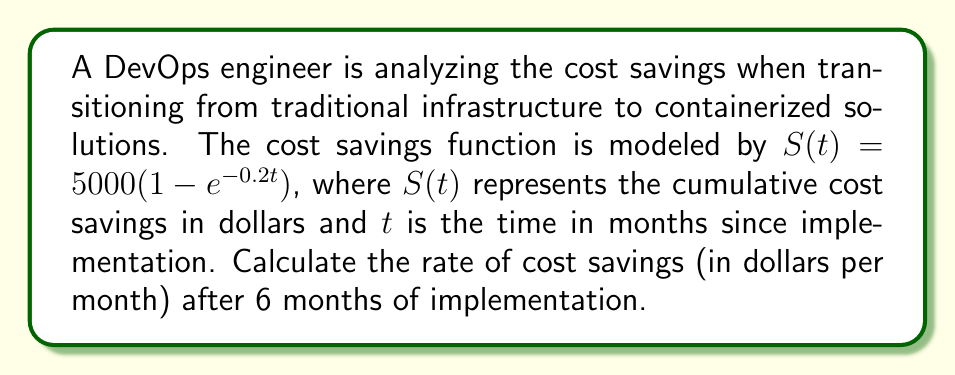What is the answer to this math problem? To find the rate of cost savings after 6 months, we need to calculate the derivative of the cost savings function $S(t)$ and evaluate it at $t=6$. Let's follow these steps:

1) The cost savings function is given by:
   $$S(t) = 5000(1 - e^{-0.2t})$$

2) To find the rate of change, we need to differentiate $S(t)$ with respect to $t$:
   $$\frac{dS}{dt} = 5000 \cdot \frac{d}{dt}(1 - e^{-0.2t})$$

3) Using the chain rule:
   $$\frac{dS}{dt} = 5000 \cdot (-1) \cdot (-0.2e^{-0.2t})$$

4) Simplifying:
   $$\frac{dS}{dt} = 1000e^{-0.2t}$$

5) This derivative represents the instantaneous rate of cost savings at any time $t$.

6) To find the rate of cost savings after 6 months, we evaluate $\frac{dS}{dt}$ at $t=6$:
   $$\frac{dS}{dt}\bigg|_{t=6} = 1000e^{-0.2(6)}$$

7) Calculating:
   $$\frac{dS}{dt}\bigg|_{t=6} = 1000e^{-1.2} \approx 301.19$$

Therefore, after 6 months of implementation, the rate of cost savings is approximately 301.19 dollars per month.
Answer: $301.19 per month 